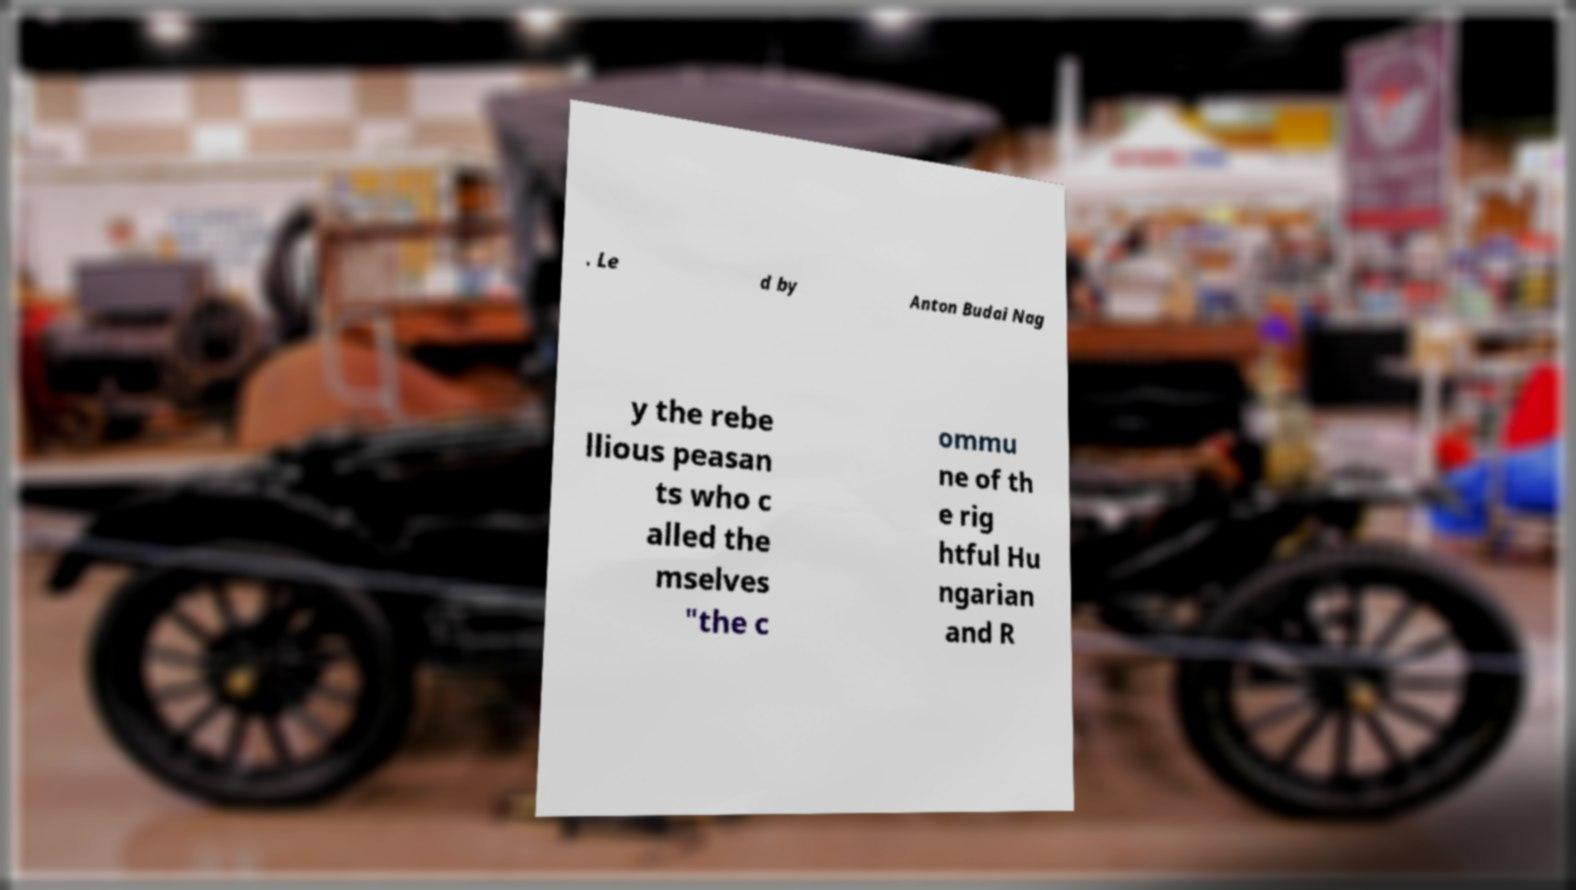Please read and relay the text visible in this image. What does it say? . Le d by Anton Budai Nag y the rebe llious peasan ts who c alled the mselves "the c ommu ne of th e rig htful Hu ngarian and R 